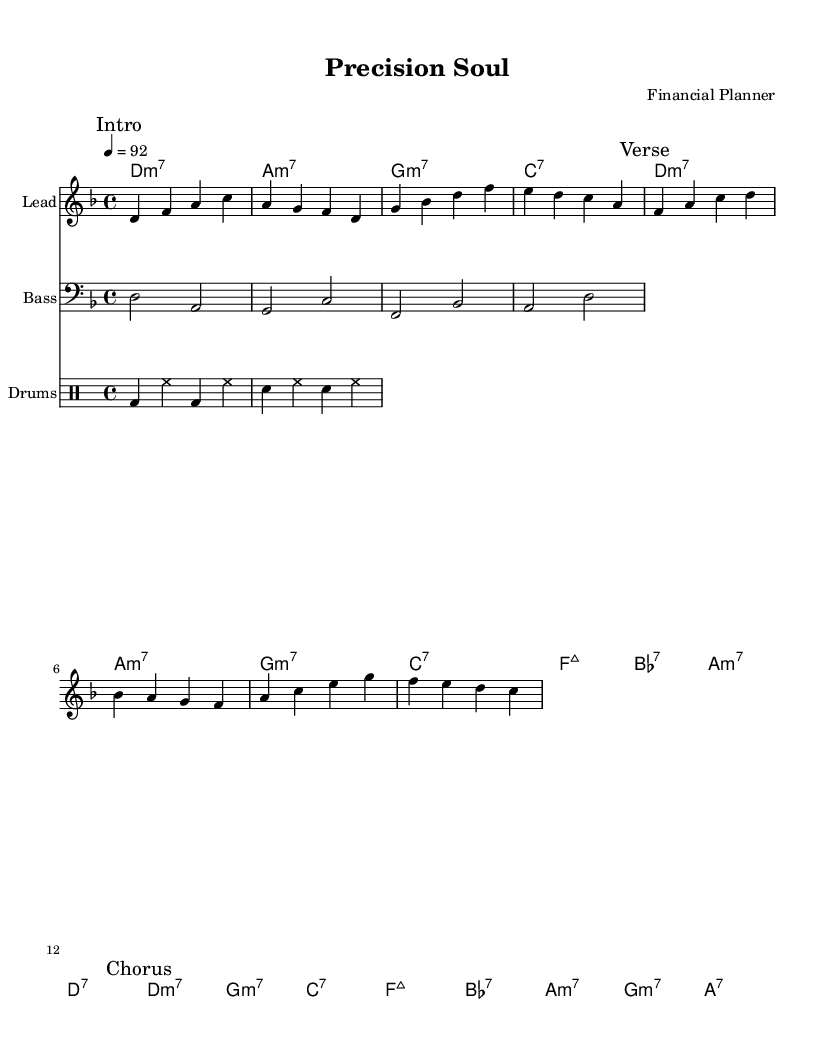What is the key signature of this music? The key signature is D minor, which has one flat (B flat). It can be identified by looking at the key signature symbol at the beginning of the staff.
Answer: D minor What is the time signature of this piece? The time signature is 4/4, which means there are four beats in each measure and the quarter note gets one beat. This can be seen next to the key signature at the beginning of the score.
Answer: 4/4 What is the tempo marking for the piece? The tempo marking is 4 equals 92. This indicates the speed of the piece, showing that there should be 92 quarter note beats per minute. This is found in the tempo indication at the beginning of the score.
Answer: 92 How many measures are in the verse section? The verse section contains 8 measures, which can be counted by looking at the measures demarcated in the melody line under the "Verse" marking.
Answer: 8 What is the chord for the first measure of the chorus? The chord for the first measure of the chorus is D minor seven. This is specified under the "Chorus" section in the chord names.
Answer: D minor seven Which chords are used in the verse section? The chords used in the verse section are D minor seven, A minor seven, G minor seven, C seven, F major seven, B flat seven, A minor seven, and D seven. This can be identified by looking at the chord names listed under the "Verse" marking.
Answer: D minor seven, A minor seven, G minor seven, C seven, F major seven, B flat seven, A minor seven, D seven What is the drum pattern used in the song? The drum pattern consists of bass drum and snare drum hits played in a consistent rhythm, indicated in the piano staff and described in drum notes. This specific pattern demonstrates the groove typical in soul music.
Answer: Bass and snare 